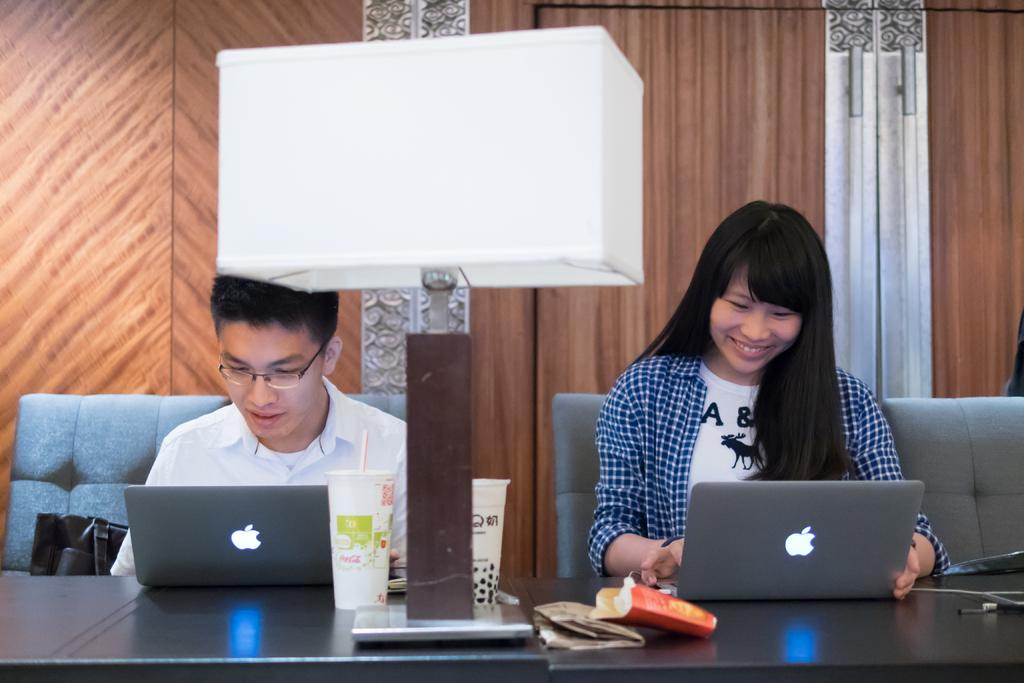How many people are present in the image? There are two people in the image, a man and a woman. What are the man and woman doing in the image? Both the man and woman are sitting on couches. What object is in front of them? There is a laptop in front of them. What type of lighting is present in the image? There is a lamp in the image. What can be seen on the wall behind the man and woman? There is a wooden wall in the image. What type of payment method is being used by the man and woman in the image? There is no indication of any payment method being used in the image, as it primarily features the man and woman sitting on couches with a laptop in front of them. 